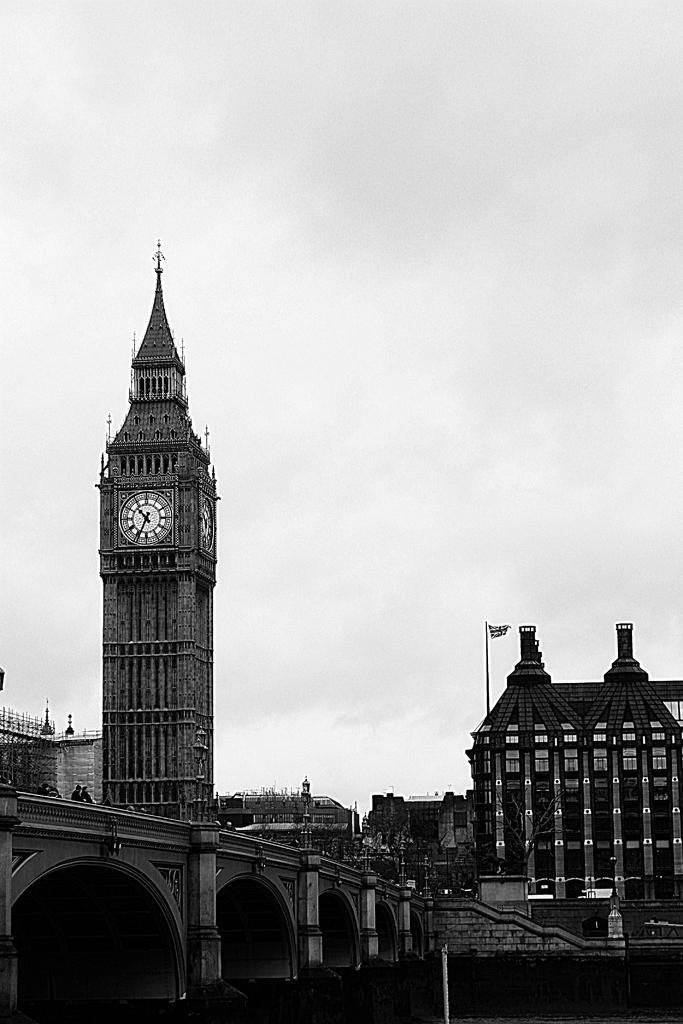Describe this image in one or two sentences. In this image we can see a bridge. On the bridge we can see the persons. Behind the persons we can see a tower and buildings. On the tower we can see a clock. There is a flag on a building. At the top we can see the sky. 